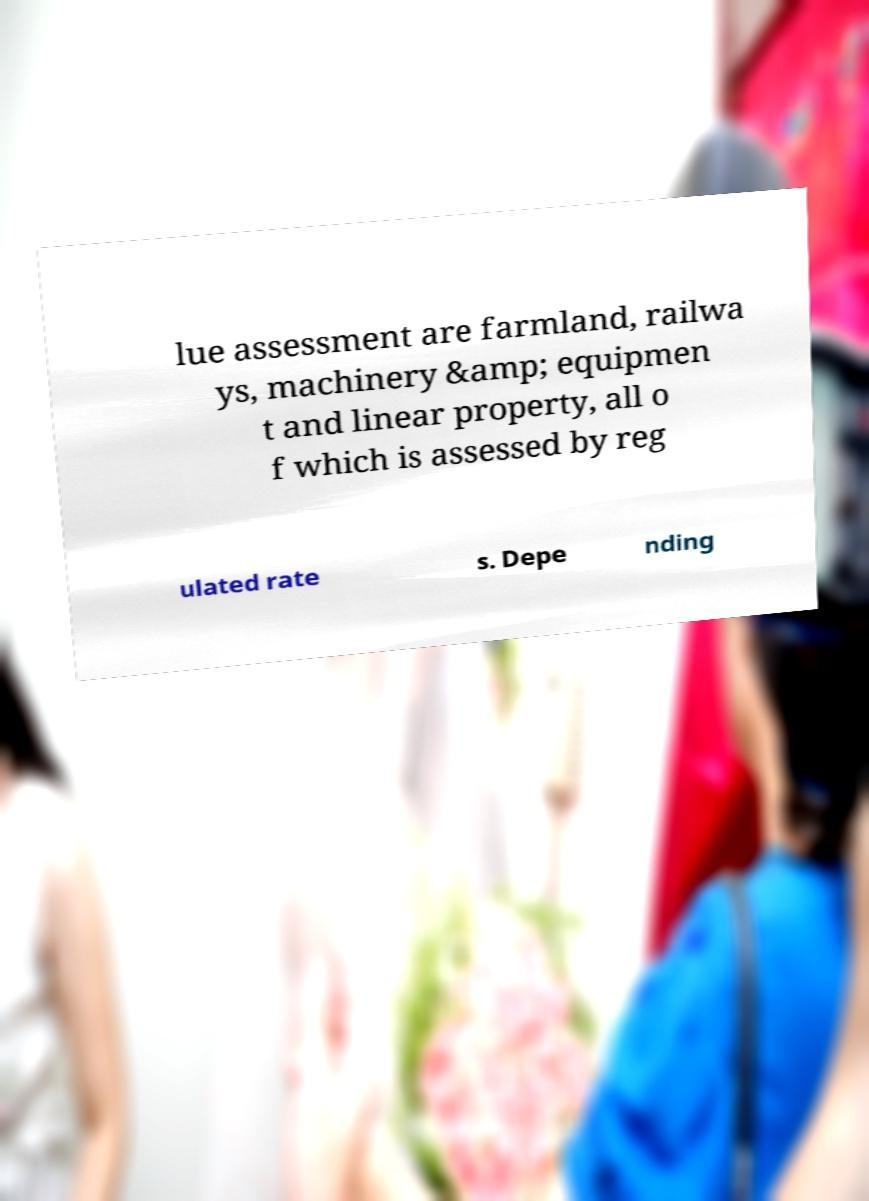Please read and relay the text visible in this image. What does it say? lue assessment are farmland, railwa ys, machinery &amp; equipmen t and linear property, all o f which is assessed by reg ulated rate s. Depe nding 